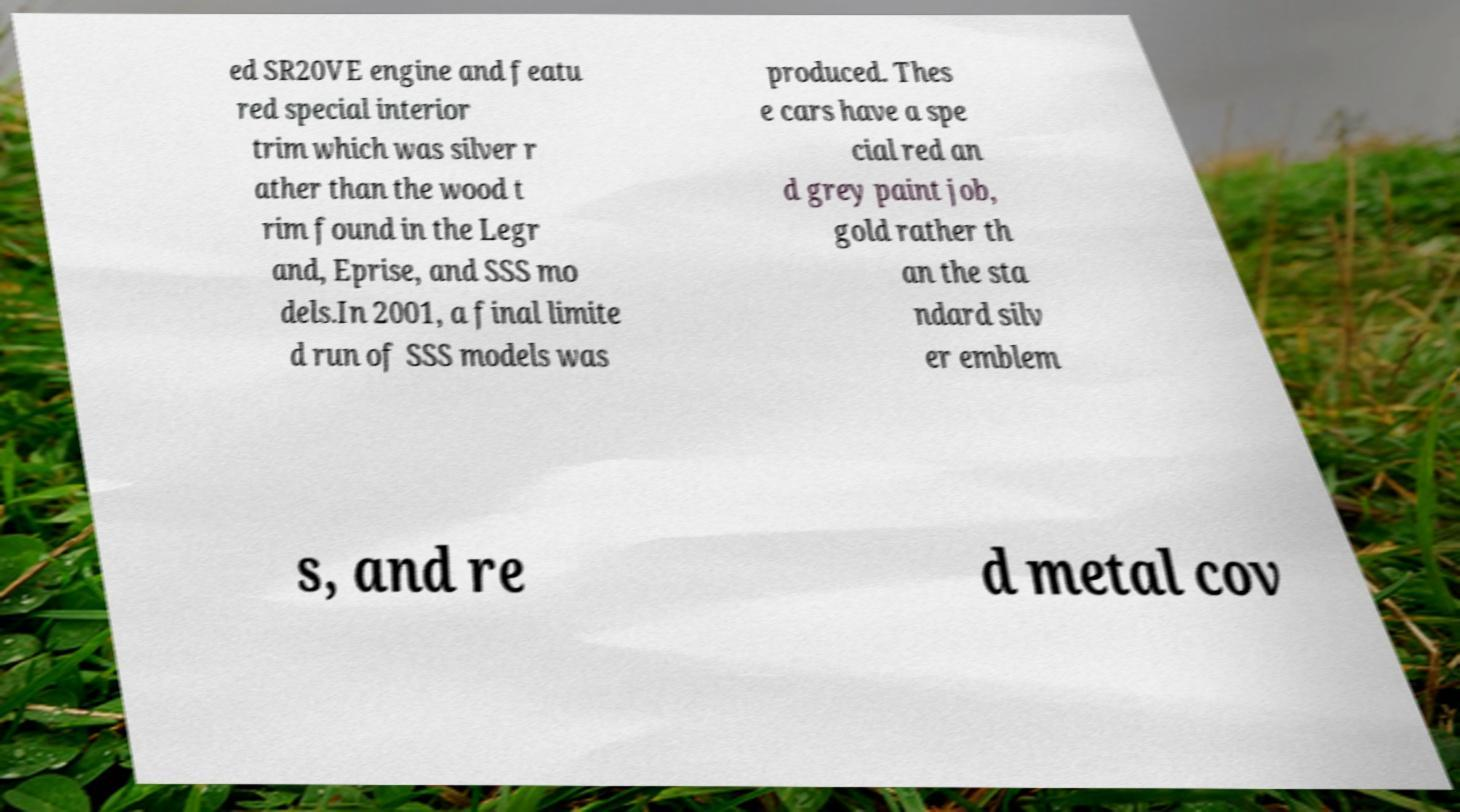There's text embedded in this image that I need extracted. Can you transcribe it verbatim? ed SR20VE engine and featu red special interior trim which was silver r ather than the wood t rim found in the Legr and, Eprise, and SSS mo dels.In 2001, a final limite d run of SSS models was produced. Thes e cars have a spe cial red an d grey paint job, gold rather th an the sta ndard silv er emblem s, and re d metal cov 